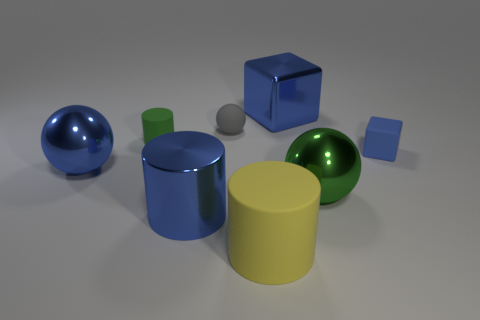Add 1 purple metal cylinders. How many objects exist? 9 Subtract all cubes. How many objects are left? 6 Subtract all tiny blue shiny cylinders. Subtract all blue rubber blocks. How many objects are left? 7 Add 1 large green shiny balls. How many large green shiny balls are left? 2 Add 2 balls. How many balls exist? 5 Subtract 1 blue cylinders. How many objects are left? 7 